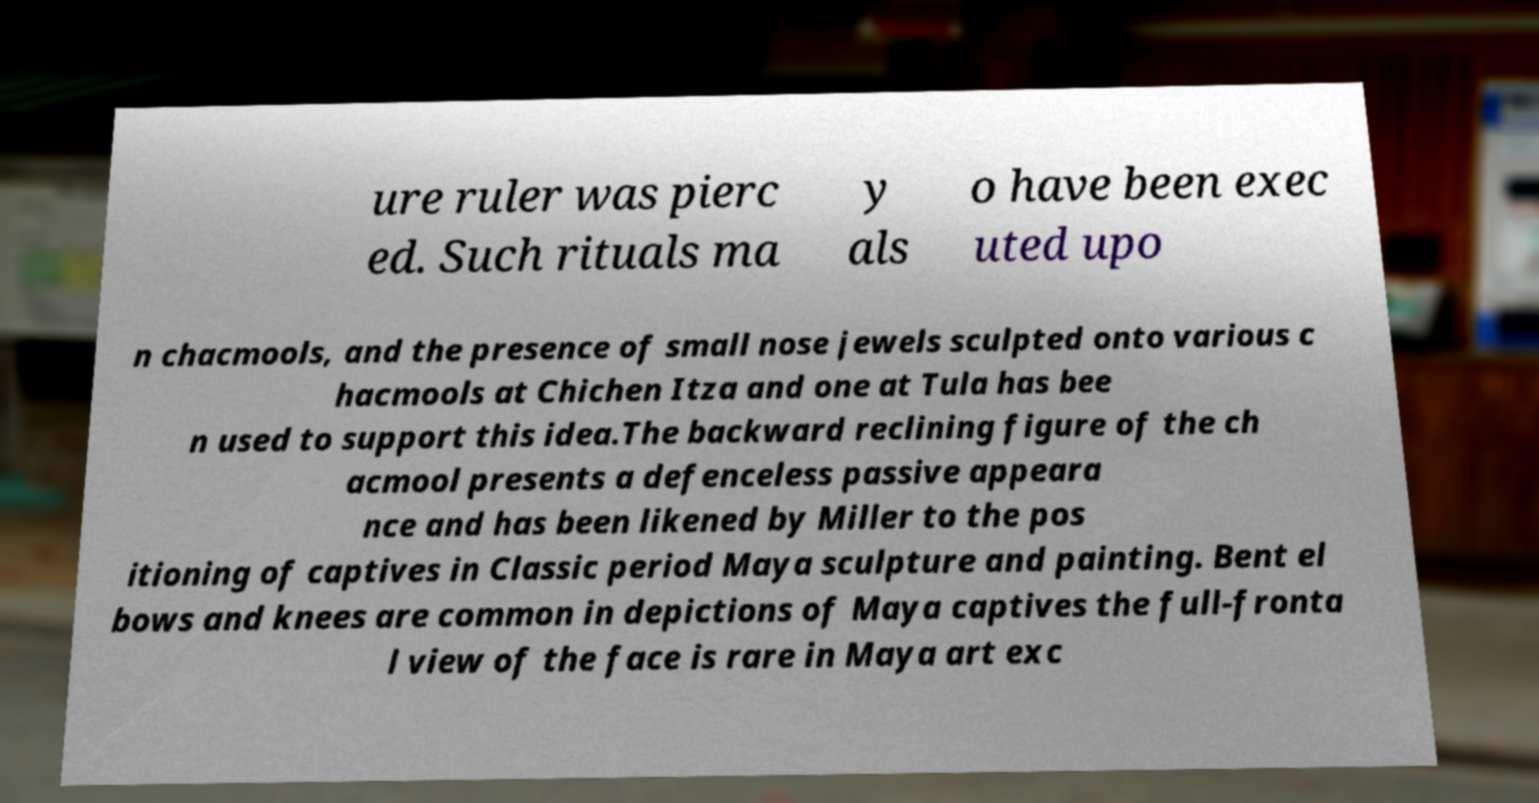Could you extract and type out the text from this image? ure ruler was pierc ed. Such rituals ma y als o have been exec uted upo n chacmools, and the presence of small nose jewels sculpted onto various c hacmools at Chichen Itza and one at Tula has bee n used to support this idea.The backward reclining figure of the ch acmool presents a defenceless passive appeara nce and has been likened by Miller to the pos itioning of captives in Classic period Maya sculpture and painting. Bent el bows and knees are common in depictions of Maya captives the full-fronta l view of the face is rare in Maya art exc 